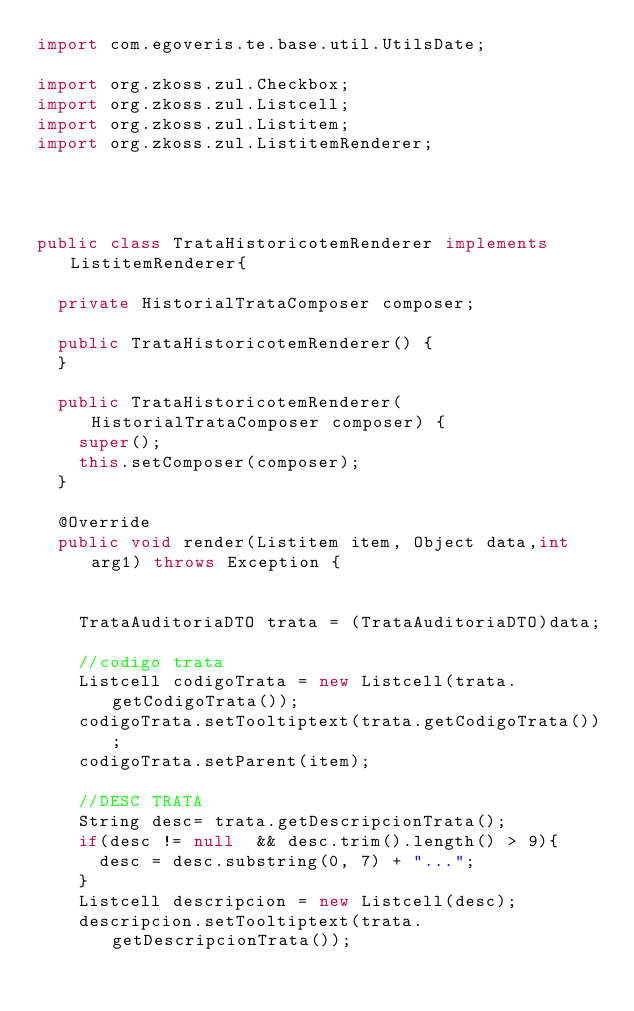<code> <loc_0><loc_0><loc_500><loc_500><_Java_>import com.egoveris.te.base.util.UtilsDate;

import org.zkoss.zul.Checkbox;
import org.zkoss.zul.Listcell;
import org.zkoss.zul.Listitem;
import org.zkoss.zul.ListitemRenderer;




public class TrataHistoricotemRenderer implements ListitemRenderer{
	
  private HistorialTrataComposer composer;
	
	public TrataHistoricotemRenderer() {
	}
	
	public TrataHistoricotemRenderer(HistorialTrataComposer composer) {
		super();
		this.setComposer(composer);
	}
	
	@Override
	public void render(Listitem item, Object data,int arg1) throws Exception {
		
	
		TrataAuditoriaDTO trata = (TrataAuditoriaDTO)data;
		
		//codigo trata
		Listcell codigoTrata = new Listcell(trata.getCodigoTrata());
		codigoTrata.setTooltiptext(trata.getCodigoTrata());
		codigoTrata.setParent(item);

		//DESC TRATA
		String desc= trata.getDescripcionTrata();
		if(desc != null  && desc.trim().length() > 9){
			desc = desc.substring(0, 7) + "...";
		}
		Listcell descripcion = new Listcell(desc);
		descripcion.setTooltiptext(trata.getDescripcionTrata());</code> 